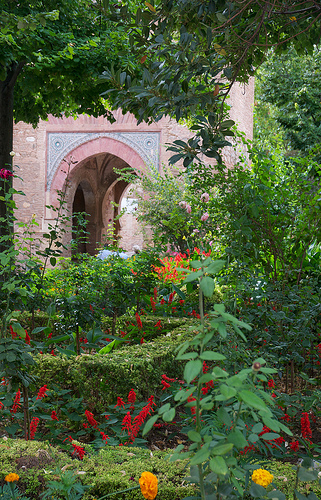<image>
Can you confirm if the flower is to the left of the gate? No. The flower is not to the left of the gate. From this viewpoint, they have a different horizontal relationship. 